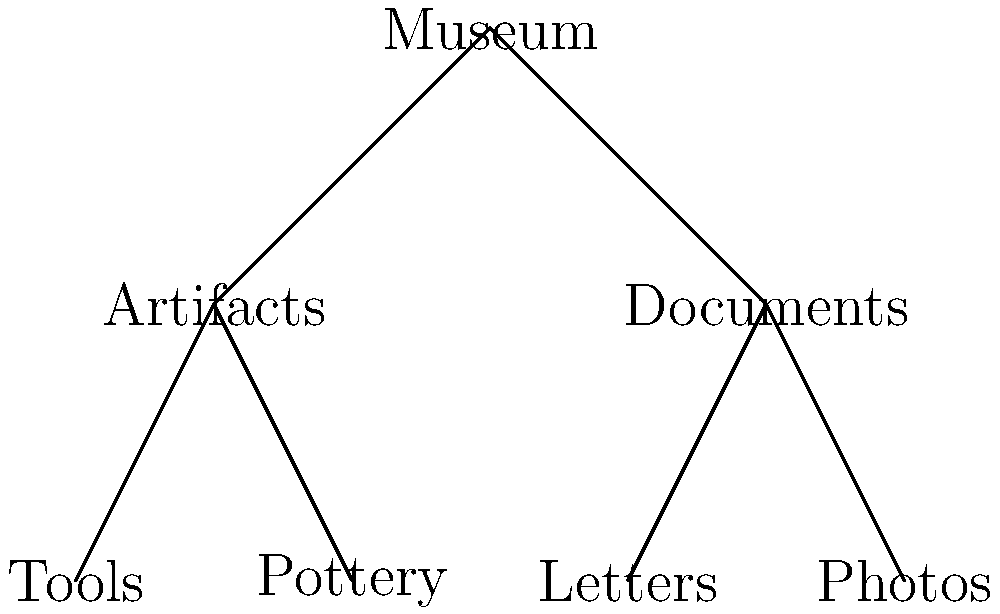In organizing your museum's collection into a hierarchical tree structure, you've created the above diagram. What is the height of this tree structure? To determine the height of the tree structure, we need to follow these steps:

1. Identify the root node: In this case, it's "Museum" at the top.

2. Count the levels:
   - Level 0: Museum (root)
   - Level 1: Artifacts, Documents
   - Level 2: Tools, Pottery, Letters, Photos

3. Calculate the height:
   The height of a tree is defined as the number of edges on the longest path from the root to a leaf node.

   In this case, the longest path is:
   Museum -> Artifacts -> Tools (or Pottery)
   OR
   Museum -> Documents -> Letters (or Photos)

   Both paths have 2 edges.

Therefore, the height of this tree structure is 2.
Answer: 2 